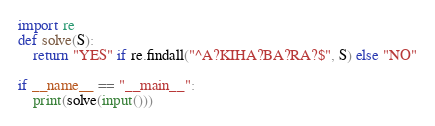<code> <loc_0><loc_0><loc_500><loc_500><_Python_>import re
def solve(S):
    return "YES" if re.findall("^A?KIHA?BA?RA?$", S) else "NO"

if __name__ == "__main__":
    print(solve(input()))
</code> 